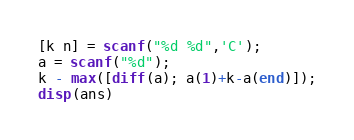<code> <loc_0><loc_0><loc_500><loc_500><_Octave_>[k n] = scanf("%d %d",'C');
a = scanf("%d");
k - max([diff(a); a(1)+k-a(end)]);
disp(ans)</code> 